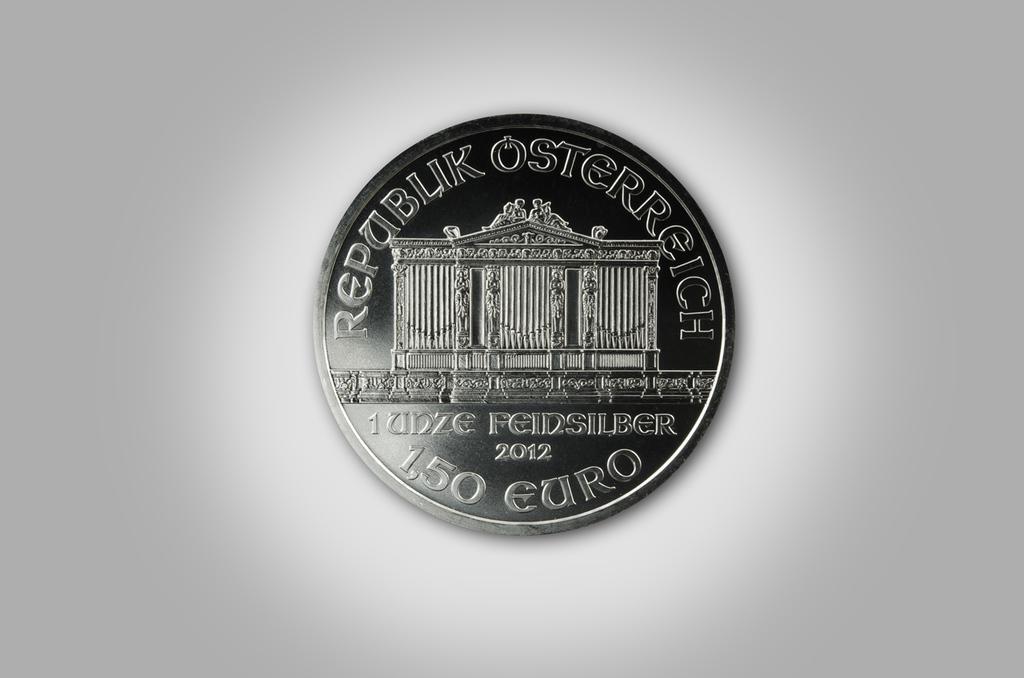Describe this image in one or two sentences. In this image I can see a coin with some text and a structure of a building. The background is in white color. 